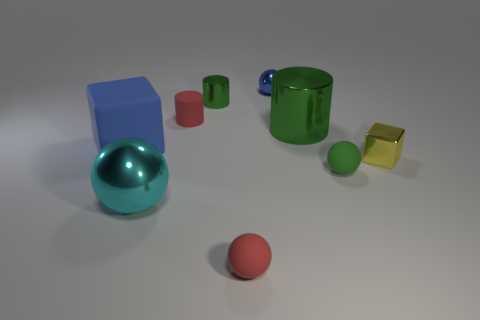Can you describe the materials of the objects in the image? Certainly! The image displays a variety of objects with different materials. The large cyan sphere and the small green sphere seem to have a metallic finish, reflective and smooth. The large cube left of the central position appears matte and likely made of plastic. The green cup and the yellow transparent cube have a glass-like quality, indicated by their shine and clarity. The red sphere has a dull, non-reflective surface that could suggest a rubber material. 